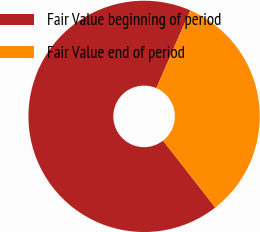<chart> <loc_0><loc_0><loc_500><loc_500><pie_chart><fcel>Fair Value beginning of period<fcel>Fair Value end of period<nl><fcel>67.09%<fcel>32.91%<nl></chart> 